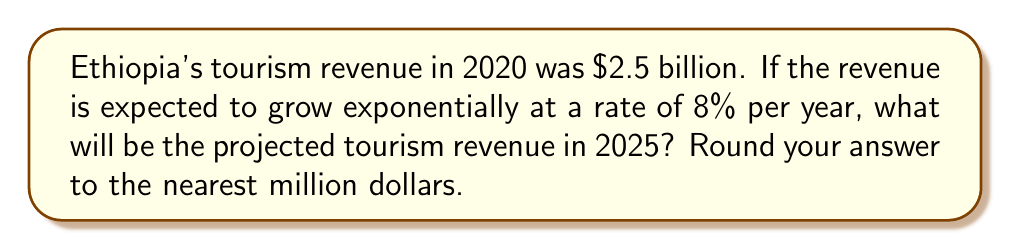What is the answer to this math problem? To solve this problem, we'll use the exponential growth formula:

$$A = P(1 + r)^t$$

Where:
$A$ = Final amount
$P$ = Initial principal balance
$r$ = Annual growth rate (as a decimal)
$t$ = Number of years

Given:
$P = 2.5$ billion dollars
$r = 8\% = 0.08$
$t = 5$ years (from 2020 to 2025)

Let's substitute these values into the formula:

$$A = 2.5(1 + 0.08)^5$$

Now, let's calculate step-by-step:

1) First, calculate $(1 + 0.08)^5$:
   $$(1.08)^5 = 1.46933...$$

2) Multiply this result by the initial amount:
   $$2.5 \times 1.46933... = 3.67332...$$

3) Round to the nearest million:
   $$3.67332... \approx 3.673 \text{ billion dollars}$$

Therefore, the projected tourism revenue in 2025 will be approximately $3.673 billion.
Answer: $3.673 billion 